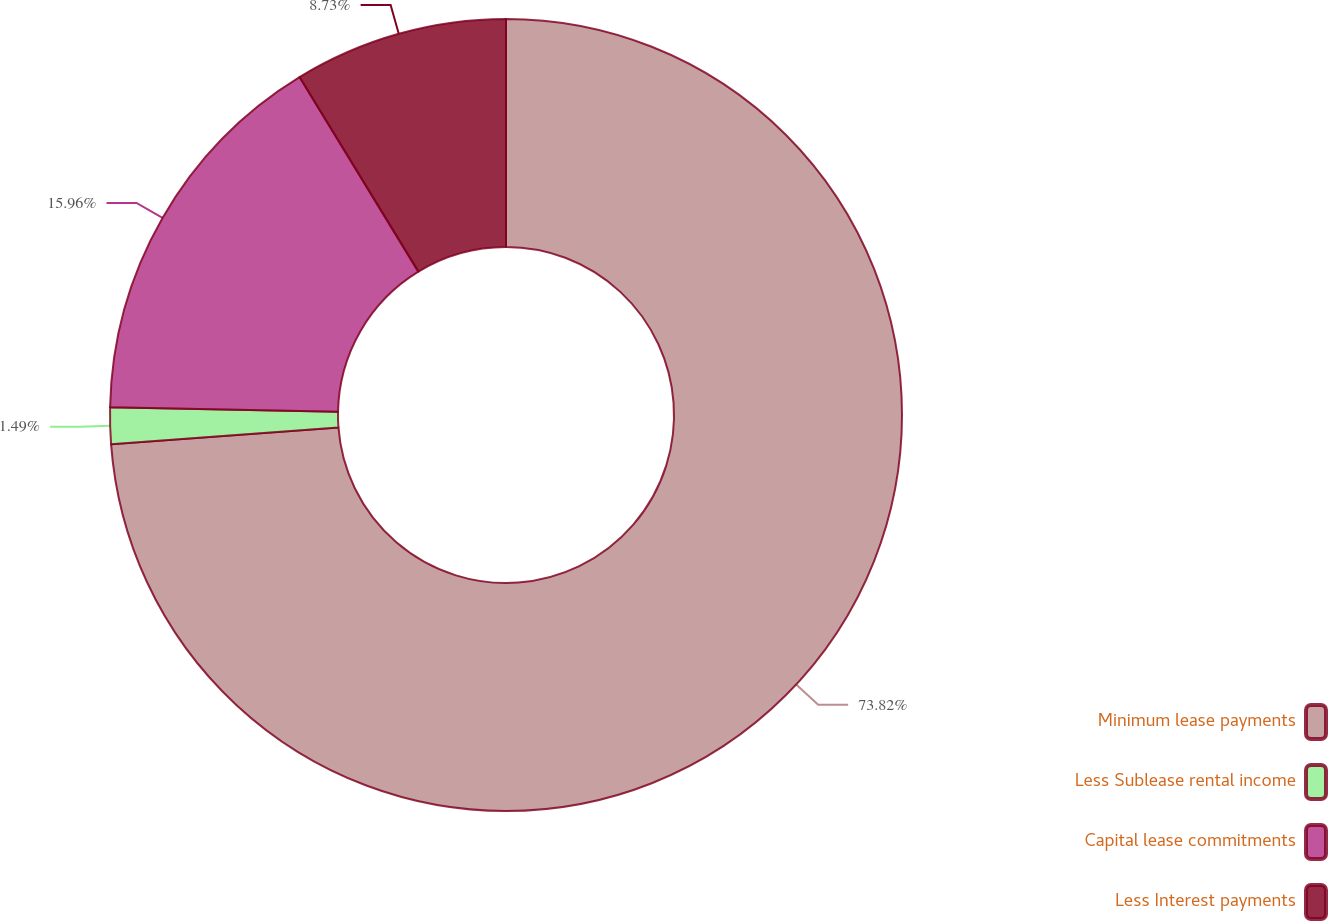Convert chart. <chart><loc_0><loc_0><loc_500><loc_500><pie_chart><fcel>Minimum lease payments<fcel>Less Sublease rental income<fcel>Capital lease commitments<fcel>Less Interest payments<nl><fcel>73.82%<fcel>1.49%<fcel>15.96%<fcel>8.73%<nl></chart> 